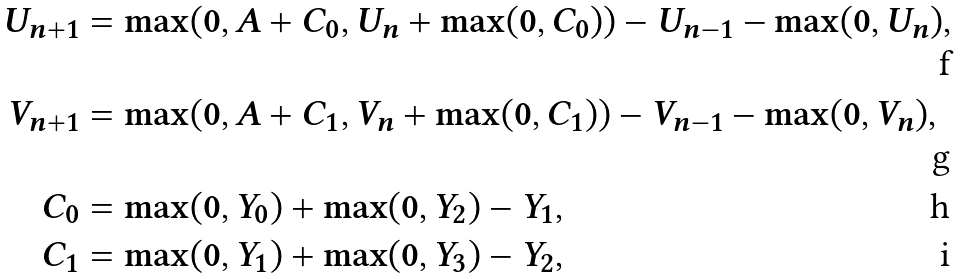Convert formula to latex. <formula><loc_0><loc_0><loc_500><loc_500>U _ { n + 1 } & = \max ( 0 , A + C _ { 0 } , U _ { n } + \max ( 0 , C _ { 0 } ) ) - U _ { n - 1 } - \max ( 0 , U _ { n } ) , \\ V _ { n + 1 } & = \max ( 0 , A + C _ { 1 } , V _ { n } + \max ( 0 , C _ { 1 } ) ) - V _ { n - 1 } - \max ( 0 , V _ { n } ) , \\ C _ { 0 } & = \max ( 0 , Y _ { 0 } ) + \max ( 0 , Y _ { 2 } ) - Y _ { 1 } , \\ C _ { 1 } & = \max ( 0 , Y _ { 1 } ) + \max ( 0 , Y _ { 3 } ) - Y _ { 2 } ,</formula> 